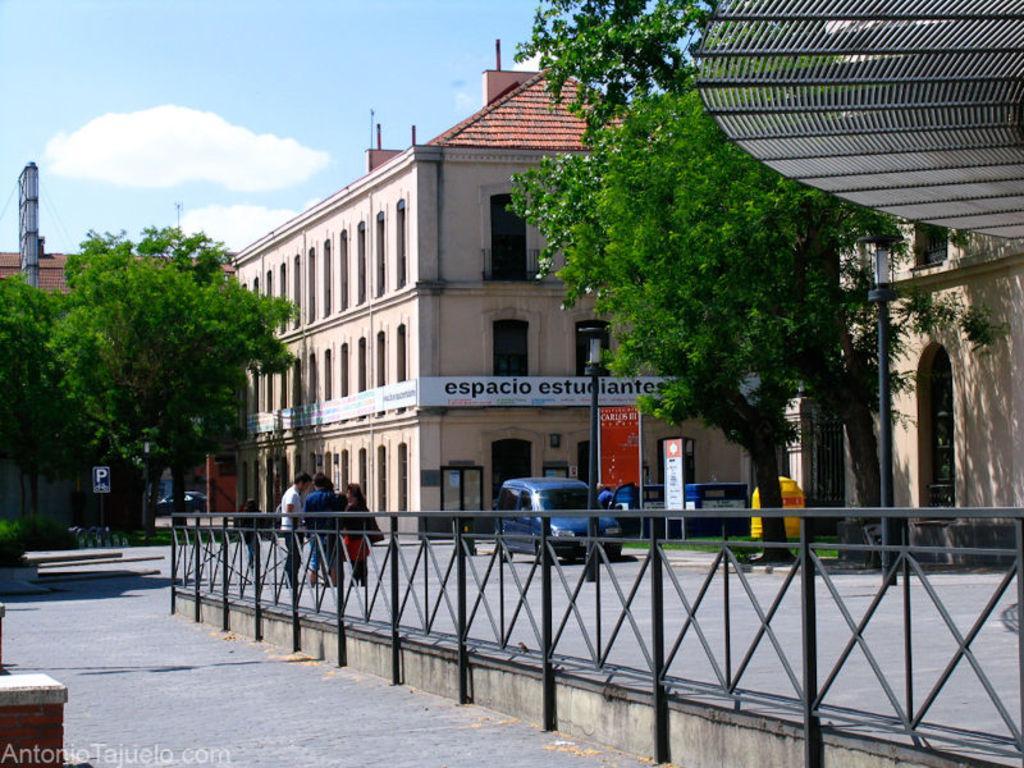Can you describe this image briefly? In this image there is a road in the middle. In the middle of the road there is an iron railing. Beside the railing there are few people who are standing on the ground. In the background there is a building. There are trees on either side of the building. On the road there are vehicles. At the top there is the sky. There are hoardings on the footpath. 